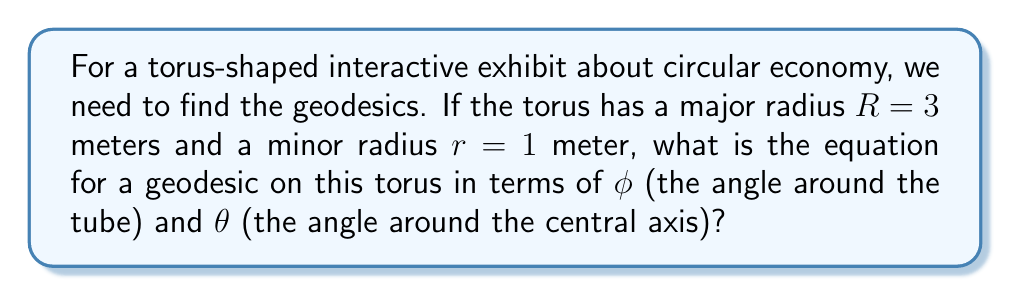Help me with this question. To find the geodesics on a torus, we need to follow these steps:

1) The parametric equations for a torus are:
   $$x = (R + r\cos\phi)\cos\theta$$
   $$y = (R + r\cos\phi)\sin\theta$$
   $$z = r\sin\phi$$

2) The geodesic equation for a torus can be derived using the Euler-Lagrange equations. It results in:
   $$\frac{d\phi}{d\theta} = \pm \sqrt{\frac{c^2(R + r\cos\phi)^2 - r^2}{r^2(R + r\cos\phi)^2}}$$
   where $c$ is a constant of integration.

3) For our specific torus with $R = 3$ and $r = 1$, we substitute these values:
   $$\frac{d\phi}{d\theta} = \pm \sqrt{\frac{c^2(3 + \cos\phi)^2 - 1}{(3 + \cos\phi)^2}}$$

4) This differential equation describes the geodesics on our torus. The constant $c$ determines the specific geodesic. Different values of $c$ will give different types of geodesics:

   - If $c > R/r = 3$, the geodesic will wind around the torus, never closing.
   - If $c = R/r = 3$, the geodesic will be a closed curve that winds once around the central axis and once around the tube.
   - If $c < R/r = 3$, the geodesic will oscillate around the outermost equator of the torus.

5) The equation in step 3 is the final form of the geodesic equation for our specific torus.
Answer: $$\frac{d\phi}{d\theta} = \pm \sqrt{\frac{c^2(3 + \cos\phi)^2 - 1}{(3 + \cos\phi)^2}}$$ 